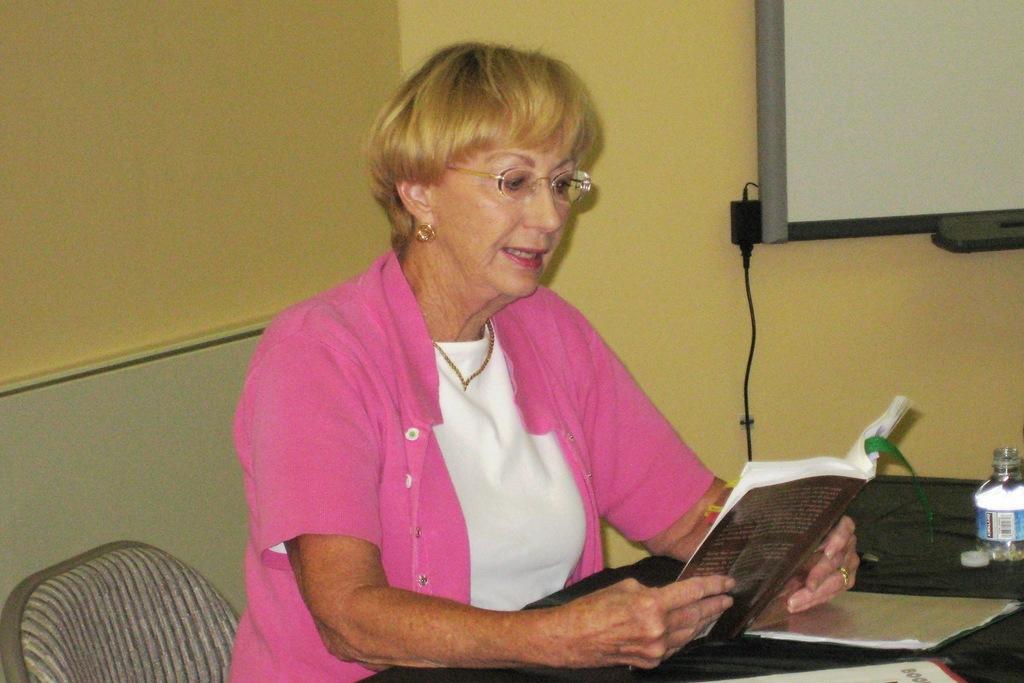Please provide a concise description of this image. In this picture there is a woman sitting and holding the book. There are books and there is a bottle on the table. At the back there is a board and there is a wire on the wall. On the left side of the image there is an object behind the chair. 